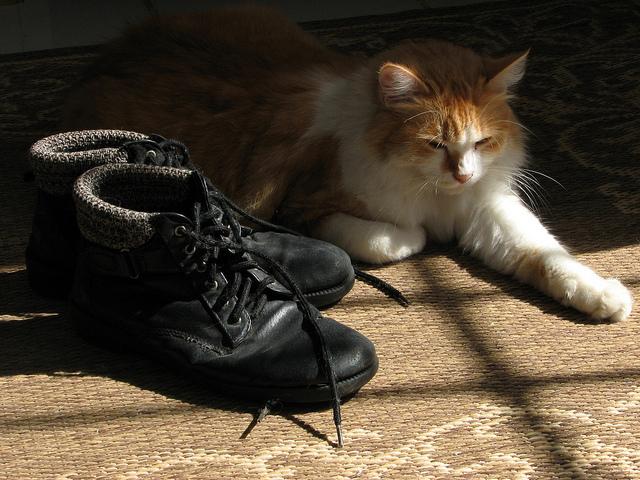Are shadows cast?
Quick response, please. Yes. Are the boot laces tied?
Short answer required. No. Is that cat angry?
Keep it brief. No. What is the cat staring at?
Answer briefly. Floor. What size boots are they?
Concise answer only. 10. 